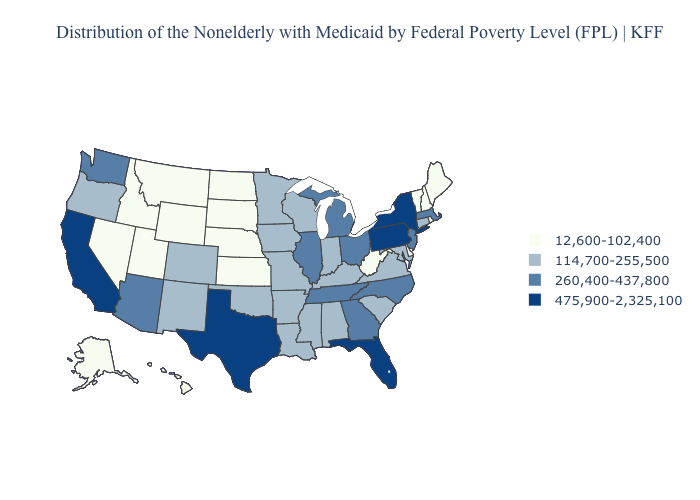What is the highest value in states that border Kansas?
Keep it brief. 114,700-255,500. Is the legend a continuous bar?
Keep it brief. No. Name the states that have a value in the range 475,900-2,325,100?
Quick response, please. California, Florida, New York, Pennsylvania, Texas. Which states have the lowest value in the West?
Quick response, please. Alaska, Hawaii, Idaho, Montana, Nevada, Utah, Wyoming. What is the lowest value in the USA?
Give a very brief answer. 12,600-102,400. What is the lowest value in the USA?
Quick response, please. 12,600-102,400. Name the states that have a value in the range 12,600-102,400?
Short answer required. Alaska, Delaware, Hawaii, Idaho, Kansas, Maine, Montana, Nebraska, Nevada, New Hampshire, North Dakota, Rhode Island, South Dakota, Utah, Vermont, West Virginia, Wyoming. What is the value of Florida?
Concise answer only. 475,900-2,325,100. What is the value of Hawaii?
Be succinct. 12,600-102,400. Name the states that have a value in the range 260,400-437,800?
Short answer required. Arizona, Georgia, Illinois, Massachusetts, Michigan, New Jersey, North Carolina, Ohio, Tennessee, Washington. Does Hawaii have a lower value than Arkansas?
Give a very brief answer. Yes. What is the value of Kansas?
Concise answer only. 12,600-102,400. Name the states that have a value in the range 12,600-102,400?
Quick response, please. Alaska, Delaware, Hawaii, Idaho, Kansas, Maine, Montana, Nebraska, Nevada, New Hampshire, North Dakota, Rhode Island, South Dakota, Utah, Vermont, West Virginia, Wyoming. Does Florida have the highest value in the South?
Be succinct. Yes. Does Florida have the highest value in the South?
Answer briefly. Yes. 